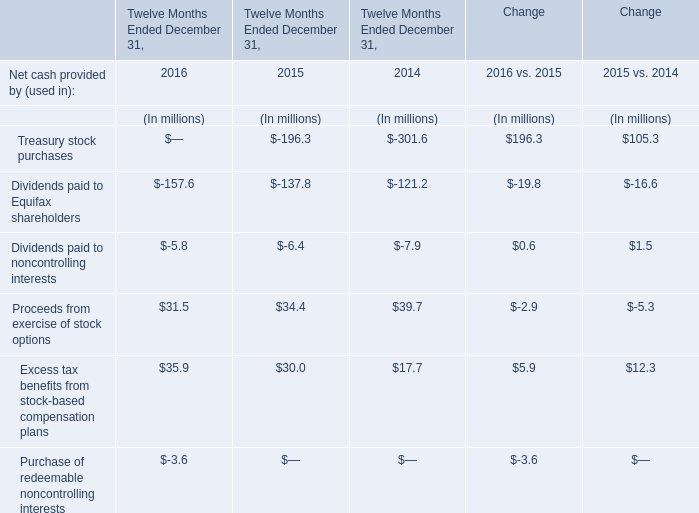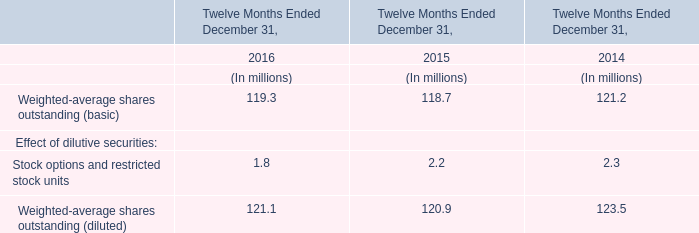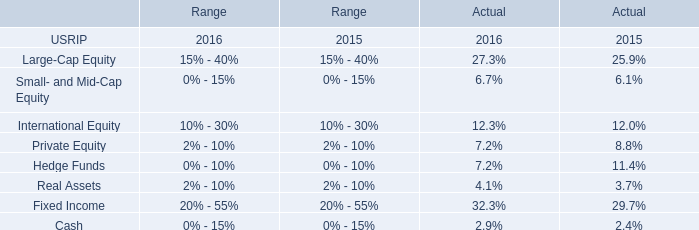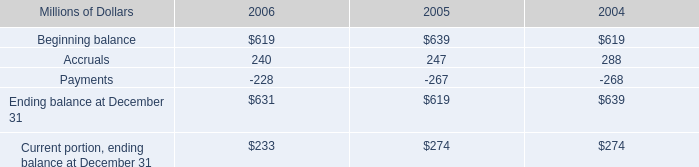What was the average value of the Dividends paid to Equifax shareholders in the years where Proceeds from exercise of stock options is positive? (in millions) 
Computations: (((-157.6 + -137.8) + -121.2) / 3)
Answer: -138.86667. 